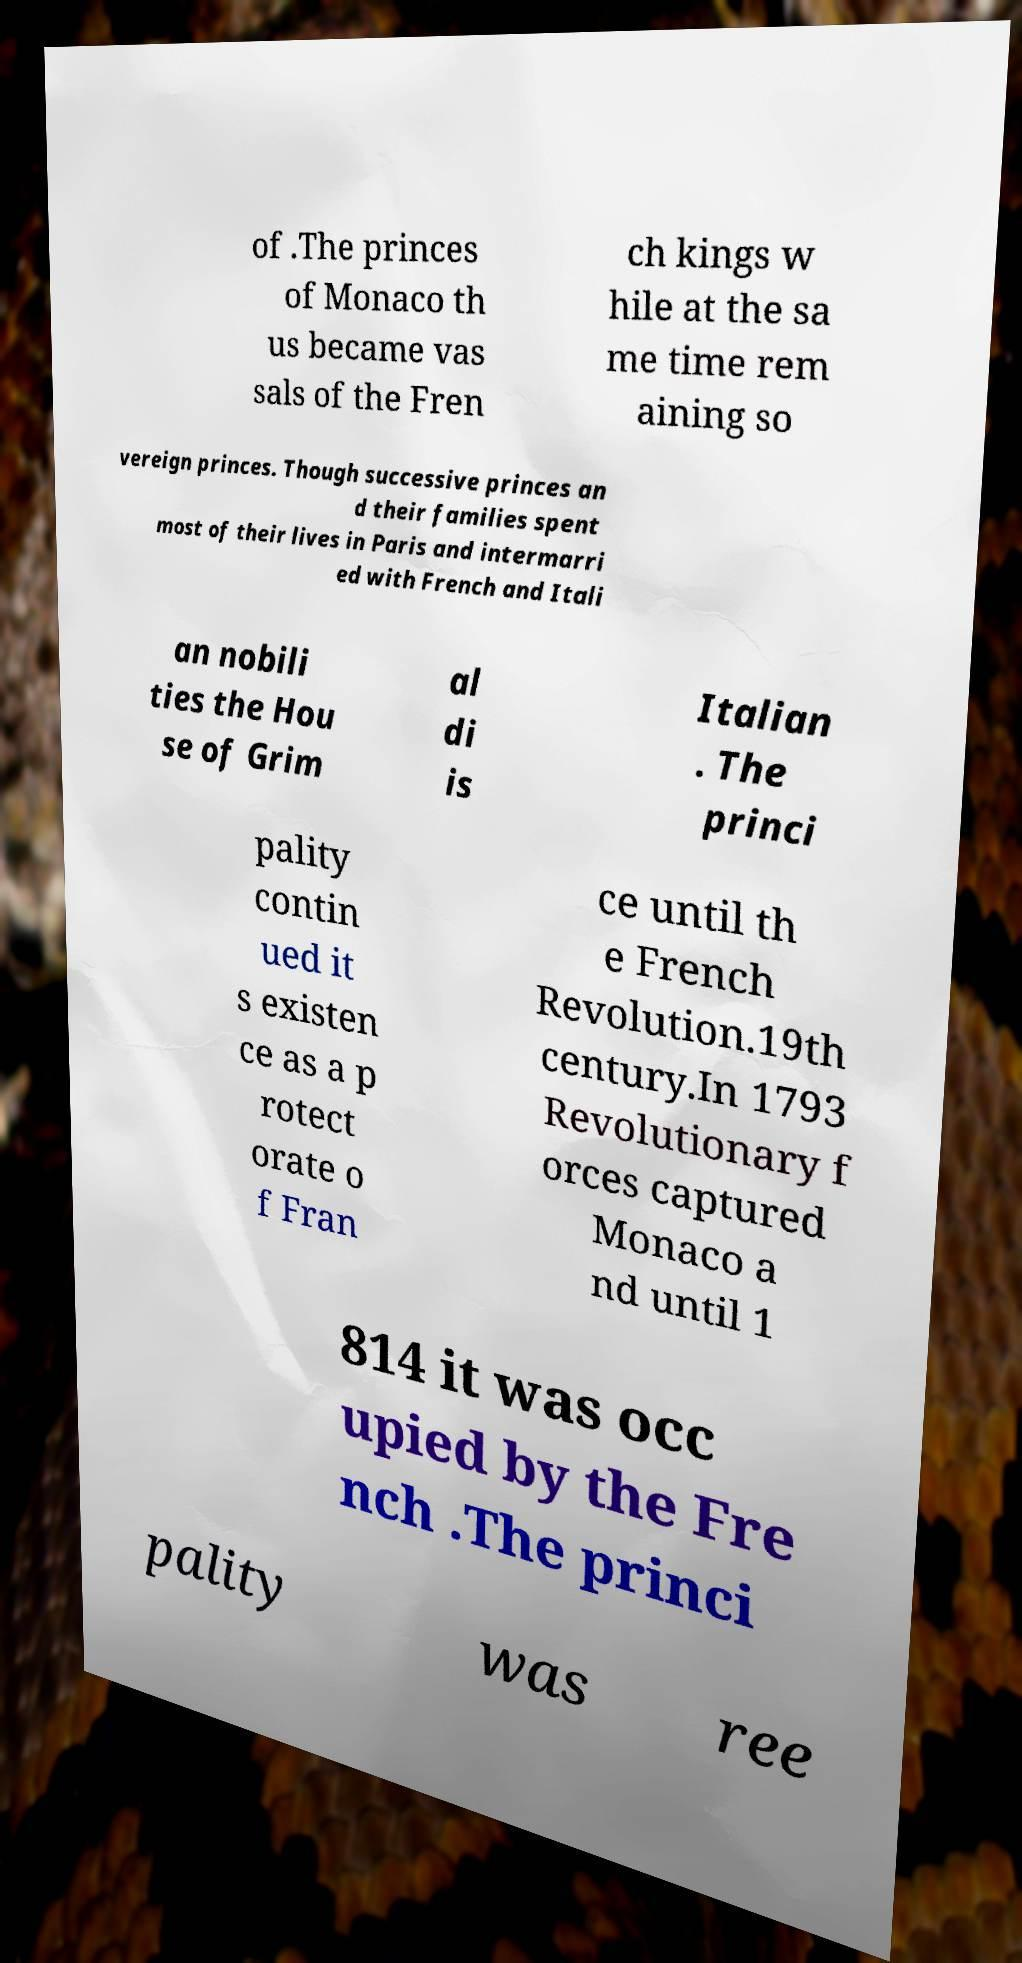Could you assist in decoding the text presented in this image and type it out clearly? of .The princes of Monaco th us became vas sals of the Fren ch kings w hile at the sa me time rem aining so vereign princes. Though successive princes an d their families spent most of their lives in Paris and intermarri ed with French and Itali an nobili ties the Hou se of Grim al di is Italian . The princi pality contin ued it s existen ce as a p rotect orate o f Fran ce until th e French Revolution.19th century.In 1793 Revolutionary f orces captured Monaco a nd until 1 814 it was occ upied by the Fre nch .The princi pality was ree 